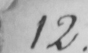Can you read and transcribe this handwriting? 12 . 